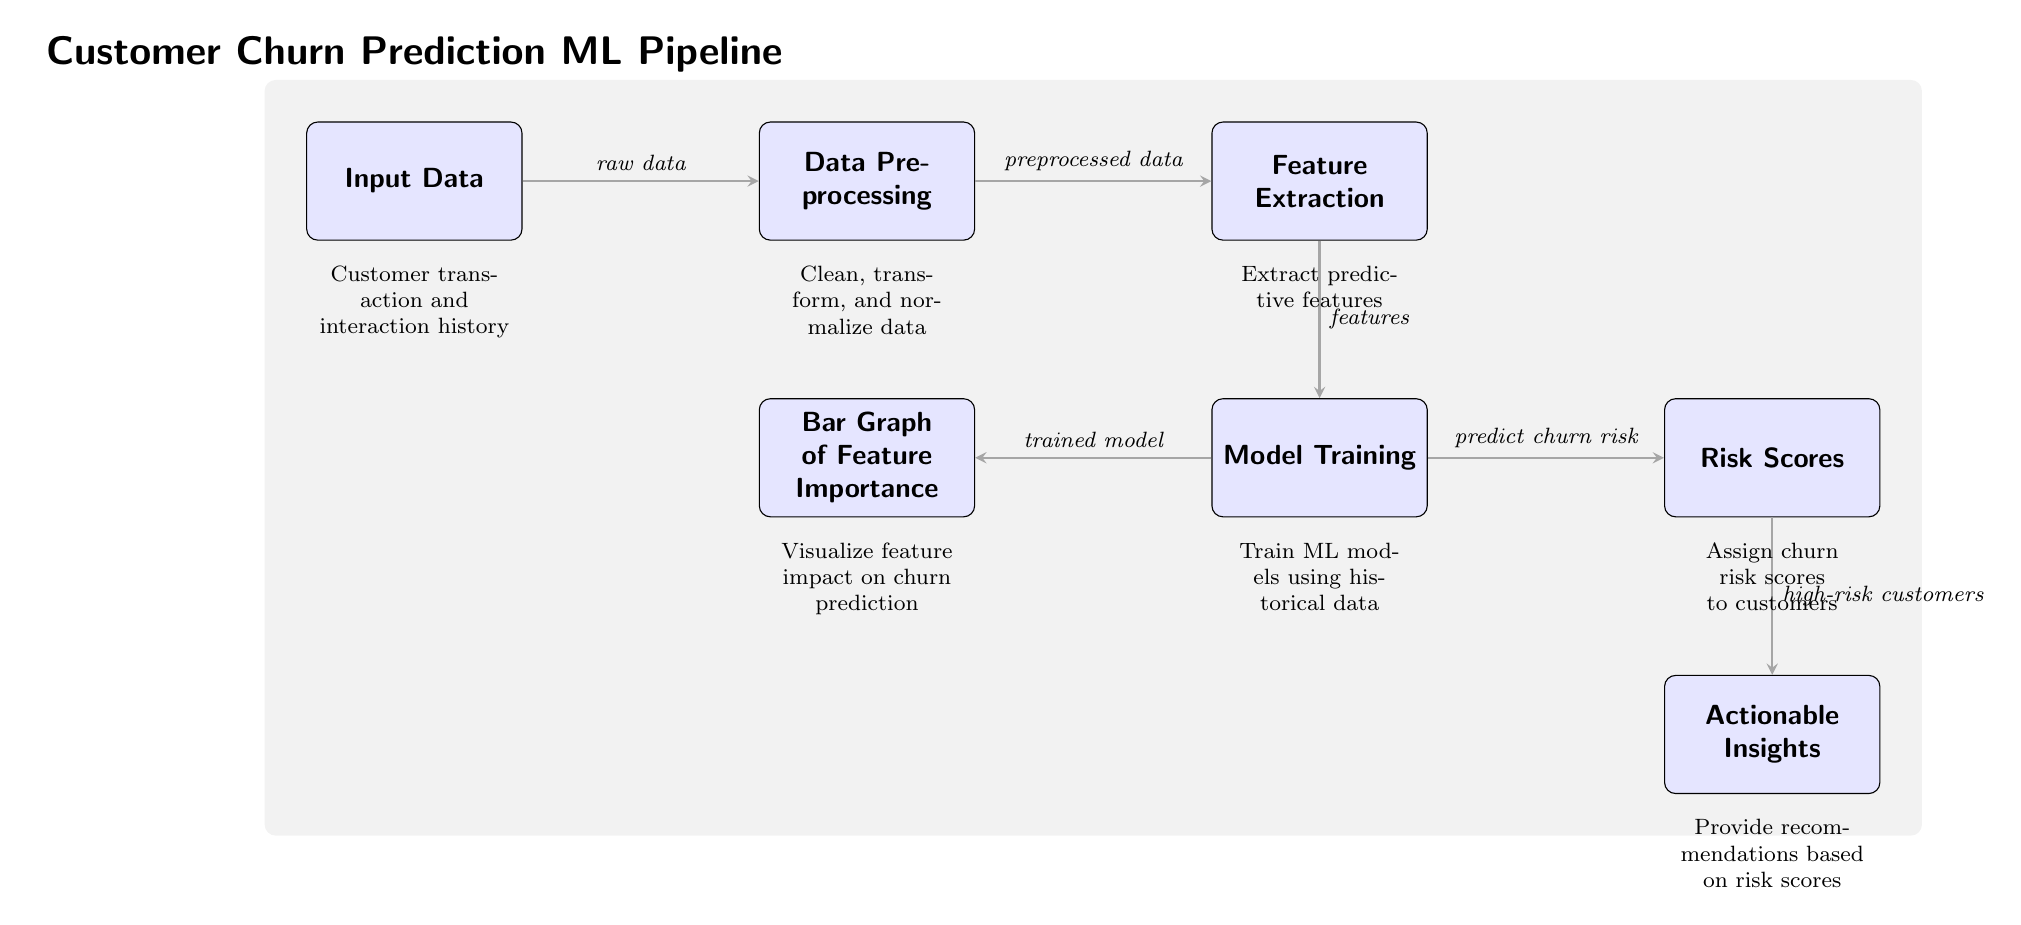What type of data is input into the pipeline? The diagram indicates that customer transaction and interaction history is the input data to the pipeline. This is the first node in the diagram and is described right below it.
Answer: Customer transaction and interaction history How many main processes are depicted in the diagram? By counting the nodes that represent main processes (Input Data, Data Preprocessing, Feature Extraction, Model Training, Feature Importance, Risk Scores, Actionable Insights), we find that there are seven distinct processes in total.
Answer: Seven What does the 'Data Preprocessing' step involve? According to the description below the 'Data Preprocessing' node, this step involves cleaning, transforming, and normalizing the data that is passed from the Input Data node.
Answer: Clean, transform, and normalize data What is the output from 'Model Training'? The outputs from 'Model Training' are two: a trained model and churn risk predictions directed towards the 'Feature Importance' node and 'Risk Scores' node, respectively. This dual output is represented by the two edges leading out from the 'Model Training' node.
Answer: Trained model and predict churn risk What action is taken for high-risk customers? The final node in the diagram indicates that actionable insights are derived from the risk scores assigned, specifically for high-risk customers, leading to recommendations based on these scores.
Answer: Provide recommendations based on risk scores How do 'Feature Extraction' and 'Model Training' connect? The connection between 'Feature Extraction' and 'Model Training' is defined by the flow indicating that features extracted from the data are used in the model training process. The edge illustrates that the features are the input to the model training step.
Answer: Features What does the final node represent? The last node in the diagram, labeled 'Actionable Insights', represents the culmination of the ML pipeline where insights and recommendations are generated based on churn risk scores from the preceding process.
Answer: Actionable Insights What is shown to visualize the churn prediction process? The diagram shows a 'Bar Graph of Feature Importance' to visualize feature impact on churn prediction, reflecting the importance of each feature in relation to churn risk.
Answer: Bar Graph of Feature Importance 